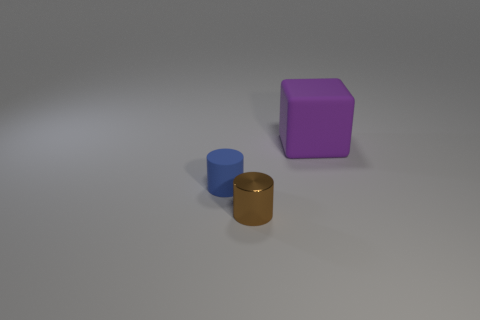Are there an equal number of large rubber things that are left of the blue rubber cylinder and blue cylinders in front of the purple rubber object? After examining the image, it appears there is one blue cylinder to the left of the golden brown cylinder which isn't made of rubber, and there are no blue cylinders in front of the purple object. Thus, the conditions described in the question don't have a matched situation in the image. 